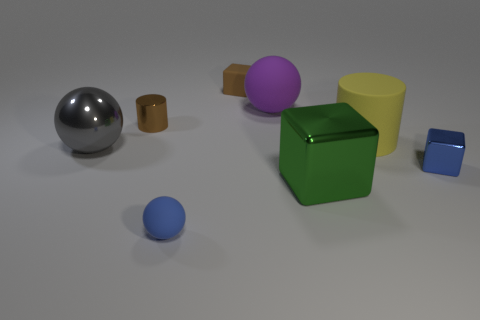Is the color of the small cylinder the same as the block that is behind the tiny shiny cylinder?
Keep it short and to the point. Yes. What material is the small blue thing that is to the left of the big ball on the right side of the small matte ball?
Provide a succinct answer. Rubber. How many rubber things are both in front of the brown rubber cube and behind the gray thing?
Your answer should be very brief. 2. What number of other things are the same size as the blue ball?
Make the answer very short. 3. Does the matte object that is in front of the tiny blue block have the same shape as the big object that is behind the yellow matte cylinder?
Your response must be concise. Yes. There is a purple ball; are there any tiny objects in front of it?
Your response must be concise. Yes. There is another big object that is the same shape as the gray object; what is its color?
Make the answer very short. Purple. What material is the large thing that is left of the large purple ball?
Make the answer very short. Metal. There is a blue rubber thing that is the same shape as the large purple matte object; what size is it?
Your answer should be very brief. Small. How many blocks are the same material as the big gray ball?
Make the answer very short. 2. 